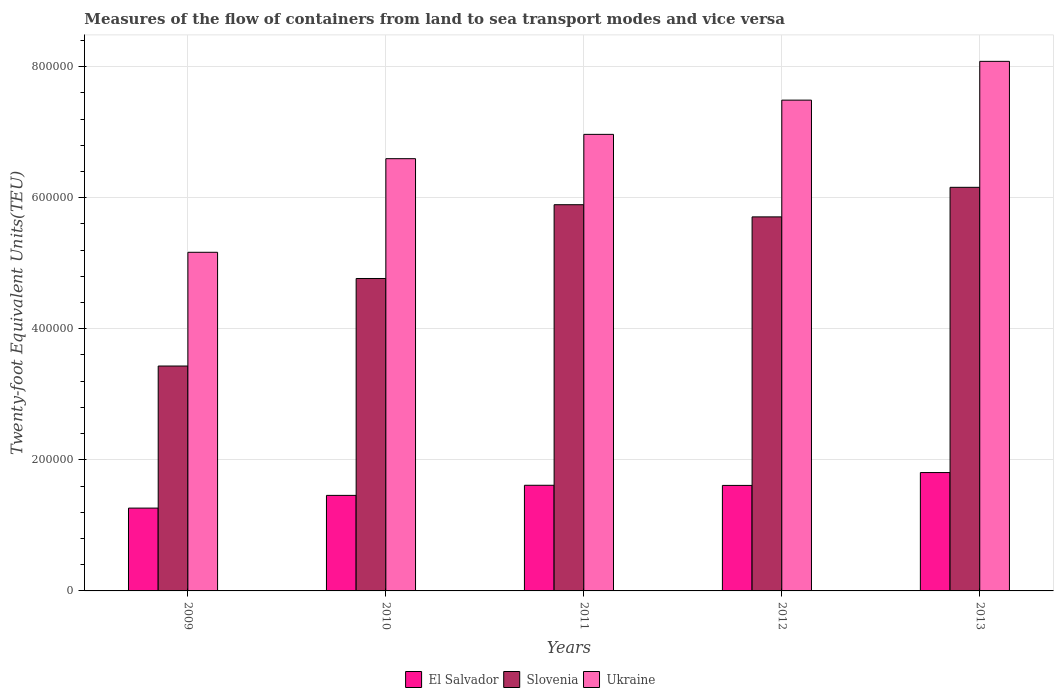How many different coloured bars are there?
Provide a short and direct response. 3. How many groups of bars are there?
Provide a short and direct response. 5. Are the number of bars on each tick of the X-axis equal?
Give a very brief answer. Yes. In how many cases, is the number of bars for a given year not equal to the number of legend labels?
Your response must be concise. 0. What is the container port traffic in Slovenia in 2009?
Keep it short and to the point. 3.43e+05. Across all years, what is the maximum container port traffic in El Salvador?
Your answer should be very brief. 1.81e+05. Across all years, what is the minimum container port traffic in Slovenia?
Your answer should be very brief. 3.43e+05. In which year was the container port traffic in El Salvador minimum?
Your answer should be compact. 2009. What is the total container port traffic in Ukraine in the graph?
Your answer should be very brief. 3.43e+06. What is the difference between the container port traffic in El Salvador in 2010 and that in 2013?
Your answer should be compact. -3.48e+04. What is the difference between the container port traffic in Slovenia in 2011 and the container port traffic in Ukraine in 2010?
Offer a very short reply. -7.02e+04. What is the average container port traffic in El Salvador per year?
Provide a short and direct response. 1.55e+05. In the year 2013, what is the difference between the container port traffic in Ukraine and container port traffic in Slovenia?
Offer a terse response. 1.92e+05. What is the ratio of the container port traffic in El Salvador in 2010 to that in 2013?
Your answer should be compact. 0.81. Is the container port traffic in El Salvador in 2011 less than that in 2012?
Keep it short and to the point. No. Is the difference between the container port traffic in Ukraine in 2011 and 2013 greater than the difference between the container port traffic in Slovenia in 2011 and 2013?
Your answer should be compact. No. What is the difference between the highest and the second highest container port traffic in Ukraine?
Your response must be concise. 5.92e+04. What is the difference between the highest and the lowest container port traffic in Ukraine?
Your answer should be compact. 2.91e+05. In how many years, is the container port traffic in Ukraine greater than the average container port traffic in Ukraine taken over all years?
Provide a succinct answer. 3. What does the 3rd bar from the left in 2010 represents?
Give a very brief answer. Ukraine. What does the 1st bar from the right in 2010 represents?
Provide a short and direct response. Ukraine. How many bars are there?
Make the answer very short. 15. Are all the bars in the graph horizontal?
Your answer should be compact. No. What is the difference between two consecutive major ticks on the Y-axis?
Offer a terse response. 2.00e+05. Does the graph contain grids?
Give a very brief answer. Yes. How are the legend labels stacked?
Make the answer very short. Horizontal. What is the title of the graph?
Make the answer very short. Measures of the flow of containers from land to sea transport modes and vice versa. Does "Grenada" appear as one of the legend labels in the graph?
Give a very brief answer. No. What is the label or title of the Y-axis?
Offer a terse response. Twenty-foot Equivalent Units(TEU). What is the Twenty-foot Equivalent Units(TEU) of El Salvador in 2009?
Keep it short and to the point. 1.26e+05. What is the Twenty-foot Equivalent Units(TEU) in Slovenia in 2009?
Give a very brief answer. 3.43e+05. What is the Twenty-foot Equivalent Units(TEU) in Ukraine in 2009?
Give a very brief answer. 5.17e+05. What is the Twenty-foot Equivalent Units(TEU) of El Salvador in 2010?
Offer a very short reply. 1.46e+05. What is the Twenty-foot Equivalent Units(TEU) in Slovenia in 2010?
Make the answer very short. 4.77e+05. What is the Twenty-foot Equivalent Units(TEU) of Ukraine in 2010?
Make the answer very short. 6.60e+05. What is the Twenty-foot Equivalent Units(TEU) in El Salvador in 2011?
Provide a short and direct response. 1.61e+05. What is the Twenty-foot Equivalent Units(TEU) in Slovenia in 2011?
Your response must be concise. 5.89e+05. What is the Twenty-foot Equivalent Units(TEU) of Ukraine in 2011?
Offer a terse response. 6.97e+05. What is the Twenty-foot Equivalent Units(TEU) in El Salvador in 2012?
Offer a terse response. 1.61e+05. What is the Twenty-foot Equivalent Units(TEU) in Slovenia in 2012?
Offer a terse response. 5.71e+05. What is the Twenty-foot Equivalent Units(TEU) of Ukraine in 2012?
Your answer should be very brief. 7.49e+05. What is the Twenty-foot Equivalent Units(TEU) in El Salvador in 2013?
Your response must be concise. 1.81e+05. What is the Twenty-foot Equivalent Units(TEU) in Slovenia in 2013?
Your response must be concise. 6.16e+05. What is the Twenty-foot Equivalent Units(TEU) of Ukraine in 2013?
Offer a very short reply. 8.08e+05. Across all years, what is the maximum Twenty-foot Equivalent Units(TEU) in El Salvador?
Provide a short and direct response. 1.81e+05. Across all years, what is the maximum Twenty-foot Equivalent Units(TEU) of Slovenia?
Your answer should be very brief. 6.16e+05. Across all years, what is the maximum Twenty-foot Equivalent Units(TEU) of Ukraine?
Your answer should be very brief. 8.08e+05. Across all years, what is the minimum Twenty-foot Equivalent Units(TEU) in El Salvador?
Keep it short and to the point. 1.26e+05. Across all years, what is the minimum Twenty-foot Equivalent Units(TEU) in Slovenia?
Provide a short and direct response. 3.43e+05. Across all years, what is the minimum Twenty-foot Equivalent Units(TEU) in Ukraine?
Provide a short and direct response. 5.17e+05. What is the total Twenty-foot Equivalent Units(TEU) of El Salvador in the graph?
Provide a short and direct response. 7.75e+05. What is the total Twenty-foot Equivalent Units(TEU) in Slovenia in the graph?
Your response must be concise. 2.60e+06. What is the total Twenty-foot Equivalent Units(TEU) of Ukraine in the graph?
Provide a short and direct response. 3.43e+06. What is the difference between the Twenty-foot Equivalent Units(TEU) of El Salvador in 2009 and that in 2010?
Make the answer very short. -1.94e+04. What is the difference between the Twenty-foot Equivalent Units(TEU) of Slovenia in 2009 and that in 2010?
Offer a very short reply. -1.34e+05. What is the difference between the Twenty-foot Equivalent Units(TEU) in Ukraine in 2009 and that in 2010?
Offer a very short reply. -1.43e+05. What is the difference between the Twenty-foot Equivalent Units(TEU) of El Salvador in 2009 and that in 2011?
Provide a short and direct response. -3.48e+04. What is the difference between the Twenty-foot Equivalent Units(TEU) in Slovenia in 2009 and that in 2011?
Ensure brevity in your answer.  -2.46e+05. What is the difference between the Twenty-foot Equivalent Units(TEU) of Ukraine in 2009 and that in 2011?
Your answer should be compact. -1.80e+05. What is the difference between the Twenty-foot Equivalent Units(TEU) in El Salvador in 2009 and that in 2012?
Your response must be concise. -3.46e+04. What is the difference between the Twenty-foot Equivalent Units(TEU) in Slovenia in 2009 and that in 2012?
Provide a succinct answer. -2.28e+05. What is the difference between the Twenty-foot Equivalent Units(TEU) in Ukraine in 2009 and that in 2012?
Make the answer very short. -2.32e+05. What is the difference between the Twenty-foot Equivalent Units(TEU) of El Salvador in 2009 and that in 2013?
Make the answer very short. -5.42e+04. What is the difference between the Twenty-foot Equivalent Units(TEU) of Slovenia in 2009 and that in 2013?
Ensure brevity in your answer.  -2.73e+05. What is the difference between the Twenty-foot Equivalent Units(TEU) in Ukraine in 2009 and that in 2013?
Provide a succinct answer. -2.91e+05. What is the difference between the Twenty-foot Equivalent Units(TEU) of El Salvador in 2010 and that in 2011?
Give a very brief answer. -1.54e+04. What is the difference between the Twenty-foot Equivalent Units(TEU) of Slovenia in 2010 and that in 2011?
Provide a succinct answer. -1.13e+05. What is the difference between the Twenty-foot Equivalent Units(TEU) of Ukraine in 2010 and that in 2011?
Offer a terse response. -3.71e+04. What is the difference between the Twenty-foot Equivalent Units(TEU) of El Salvador in 2010 and that in 2012?
Make the answer very short. -1.52e+04. What is the difference between the Twenty-foot Equivalent Units(TEU) of Slovenia in 2010 and that in 2012?
Offer a very short reply. -9.40e+04. What is the difference between the Twenty-foot Equivalent Units(TEU) of Ukraine in 2010 and that in 2012?
Provide a short and direct response. -8.93e+04. What is the difference between the Twenty-foot Equivalent Units(TEU) of El Salvador in 2010 and that in 2013?
Offer a terse response. -3.48e+04. What is the difference between the Twenty-foot Equivalent Units(TEU) in Slovenia in 2010 and that in 2013?
Keep it short and to the point. -1.39e+05. What is the difference between the Twenty-foot Equivalent Units(TEU) of Ukraine in 2010 and that in 2013?
Your answer should be very brief. -1.49e+05. What is the difference between the Twenty-foot Equivalent Units(TEU) of Slovenia in 2011 and that in 2012?
Offer a very short reply. 1.86e+04. What is the difference between the Twenty-foot Equivalent Units(TEU) in Ukraine in 2011 and that in 2012?
Keep it short and to the point. -5.22e+04. What is the difference between the Twenty-foot Equivalent Units(TEU) of El Salvador in 2011 and that in 2013?
Your answer should be compact. -1.94e+04. What is the difference between the Twenty-foot Equivalent Units(TEU) of Slovenia in 2011 and that in 2013?
Your response must be concise. -2.65e+04. What is the difference between the Twenty-foot Equivalent Units(TEU) in Ukraine in 2011 and that in 2013?
Offer a terse response. -1.11e+05. What is the difference between the Twenty-foot Equivalent Units(TEU) in El Salvador in 2012 and that in 2013?
Make the answer very short. -1.96e+04. What is the difference between the Twenty-foot Equivalent Units(TEU) of Slovenia in 2012 and that in 2013?
Your answer should be compact. -4.51e+04. What is the difference between the Twenty-foot Equivalent Units(TEU) of Ukraine in 2012 and that in 2013?
Give a very brief answer. -5.92e+04. What is the difference between the Twenty-foot Equivalent Units(TEU) in El Salvador in 2009 and the Twenty-foot Equivalent Units(TEU) in Slovenia in 2010?
Ensure brevity in your answer.  -3.50e+05. What is the difference between the Twenty-foot Equivalent Units(TEU) of El Salvador in 2009 and the Twenty-foot Equivalent Units(TEU) of Ukraine in 2010?
Keep it short and to the point. -5.33e+05. What is the difference between the Twenty-foot Equivalent Units(TEU) of Slovenia in 2009 and the Twenty-foot Equivalent Units(TEU) of Ukraine in 2010?
Your answer should be compact. -3.16e+05. What is the difference between the Twenty-foot Equivalent Units(TEU) of El Salvador in 2009 and the Twenty-foot Equivalent Units(TEU) of Slovenia in 2011?
Make the answer very short. -4.63e+05. What is the difference between the Twenty-foot Equivalent Units(TEU) in El Salvador in 2009 and the Twenty-foot Equivalent Units(TEU) in Ukraine in 2011?
Your response must be concise. -5.70e+05. What is the difference between the Twenty-foot Equivalent Units(TEU) of Slovenia in 2009 and the Twenty-foot Equivalent Units(TEU) of Ukraine in 2011?
Your response must be concise. -3.53e+05. What is the difference between the Twenty-foot Equivalent Units(TEU) of El Salvador in 2009 and the Twenty-foot Equivalent Units(TEU) of Slovenia in 2012?
Provide a short and direct response. -4.44e+05. What is the difference between the Twenty-foot Equivalent Units(TEU) of El Salvador in 2009 and the Twenty-foot Equivalent Units(TEU) of Ukraine in 2012?
Your answer should be very brief. -6.23e+05. What is the difference between the Twenty-foot Equivalent Units(TEU) in Slovenia in 2009 and the Twenty-foot Equivalent Units(TEU) in Ukraine in 2012?
Your answer should be very brief. -4.06e+05. What is the difference between the Twenty-foot Equivalent Units(TEU) of El Salvador in 2009 and the Twenty-foot Equivalent Units(TEU) of Slovenia in 2013?
Give a very brief answer. -4.89e+05. What is the difference between the Twenty-foot Equivalent Units(TEU) of El Salvador in 2009 and the Twenty-foot Equivalent Units(TEU) of Ukraine in 2013?
Keep it short and to the point. -6.82e+05. What is the difference between the Twenty-foot Equivalent Units(TEU) in Slovenia in 2009 and the Twenty-foot Equivalent Units(TEU) in Ukraine in 2013?
Provide a succinct answer. -4.65e+05. What is the difference between the Twenty-foot Equivalent Units(TEU) of El Salvador in 2010 and the Twenty-foot Equivalent Units(TEU) of Slovenia in 2011?
Offer a very short reply. -4.44e+05. What is the difference between the Twenty-foot Equivalent Units(TEU) of El Salvador in 2010 and the Twenty-foot Equivalent Units(TEU) of Ukraine in 2011?
Keep it short and to the point. -5.51e+05. What is the difference between the Twenty-foot Equivalent Units(TEU) in Slovenia in 2010 and the Twenty-foot Equivalent Units(TEU) in Ukraine in 2011?
Offer a terse response. -2.20e+05. What is the difference between the Twenty-foot Equivalent Units(TEU) in El Salvador in 2010 and the Twenty-foot Equivalent Units(TEU) in Slovenia in 2012?
Give a very brief answer. -4.25e+05. What is the difference between the Twenty-foot Equivalent Units(TEU) of El Salvador in 2010 and the Twenty-foot Equivalent Units(TEU) of Ukraine in 2012?
Give a very brief answer. -6.03e+05. What is the difference between the Twenty-foot Equivalent Units(TEU) in Slovenia in 2010 and the Twenty-foot Equivalent Units(TEU) in Ukraine in 2012?
Your answer should be compact. -2.72e+05. What is the difference between the Twenty-foot Equivalent Units(TEU) in El Salvador in 2010 and the Twenty-foot Equivalent Units(TEU) in Slovenia in 2013?
Ensure brevity in your answer.  -4.70e+05. What is the difference between the Twenty-foot Equivalent Units(TEU) of El Salvador in 2010 and the Twenty-foot Equivalent Units(TEU) of Ukraine in 2013?
Your answer should be compact. -6.62e+05. What is the difference between the Twenty-foot Equivalent Units(TEU) of Slovenia in 2010 and the Twenty-foot Equivalent Units(TEU) of Ukraine in 2013?
Your answer should be very brief. -3.31e+05. What is the difference between the Twenty-foot Equivalent Units(TEU) in El Salvador in 2011 and the Twenty-foot Equivalent Units(TEU) in Slovenia in 2012?
Ensure brevity in your answer.  -4.10e+05. What is the difference between the Twenty-foot Equivalent Units(TEU) in El Salvador in 2011 and the Twenty-foot Equivalent Units(TEU) in Ukraine in 2012?
Give a very brief answer. -5.88e+05. What is the difference between the Twenty-foot Equivalent Units(TEU) of Slovenia in 2011 and the Twenty-foot Equivalent Units(TEU) of Ukraine in 2012?
Provide a succinct answer. -1.60e+05. What is the difference between the Twenty-foot Equivalent Units(TEU) of El Salvador in 2011 and the Twenty-foot Equivalent Units(TEU) of Slovenia in 2013?
Your answer should be very brief. -4.55e+05. What is the difference between the Twenty-foot Equivalent Units(TEU) in El Salvador in 2011 and the Twenty-foot Equivalent Units(TEU) in Ukraine in 2013?
Provide a succinct answer. -6.47e+05. What is the difference between the Twenty-foot Equivalent Units(TEU) of Slovenia in 2011 and the Twenty-foot Equivalent Units(TEU) of Ukraine in 2013?
Provide a succinct answer. -2.19e+05. What is the difference between the Twenty-foot Equivalent Units(TEU) in El Salvador in 2012 and the Twenty-foot Equivalent Units(TEU) in Slovenia in 2013?
Your response must be concise. -4.55e+05. What is the difference between the Twenty-foot Equivalent Units(TEU) in El Salvador in 2012 and the Twenty-foot Equivalent Units(TEU) in Ukraine in 2013?
Your response must be concise. -6.47e+05. What is the difference between the Twenty-foot Equivalent Units(TEU) of Slovenia in 2012 and the Twenty-foot Equivalent Units(TEU) of Ukraine in 2013?
Provide a succinct answer. -2.37e+05. What is the average Twenty-foot Equivalent Units(TEU) of El Salvador per year?
Make the answer very short. 1.55e+05. What is the average Twenty-foot Equivalent Units(TEU) in Slovenia per year?
Offer a very short reply. 5.19e+05. What is the average Twenty-foot Equivalent Units(TEU) of Ukraine per year?
Your answer should be very brief. 6.86e+05. In the year 2009, what is the difference between the Twenty-foot Equivalent Units(TEU) in El Salvador and Twenty-foot Equivalent Units(TEU) in Slovenia?
Provide a short and direct response. -2.17e+05. In the year 2009, what is the difference between the Twenty-foot Equivalent Units(TEU) of El Salvador and Twenty-foot Equivalent Units(TEU) of Ukraine?
Your answer should be compact. -3.90e+05. In the year 2009, what is the difference between the Twenty-foot Equivalent Units(TEU) in Slovenia and Twenty-foot Equivalent Units(TEU) in Ukraine?
Ensure brevity in your answer.  -1.74e+05. In the year 2010, what is the difference between the Twenty-foot Equivalent Units(TEU) in El Salvador and Twenty-foot Equivalent Units(TEU) in Slovenia?
Keep it short and to the point. -3.31e+05. In the year 2010, what is the difference between the Twenty-foot Equivalent Units(TEU) of El Salvador and Twenty-foot Equivalent Units(TEU) of Ukraine?
Make the answer very short. -5.14e+05. In the year 2010, what is the difference between the Twenty-foot Equivalent Units(TEU) in Slovenia and Twenty-foot Equivalent Units(TEU) in Ukraine?
Your response must be concise. -1.83e+05. In the year 2011, what is the difference between the Twenty-foot Equivalent Units(TEU) of El Salvador and Twenty-foot Equivalent Units(TEU) of Slovenia?
Provide a succinct answer. -4.28e+05. In the year 2011, what is the difference between the Twenty-foot Equivalent Units(TEU) of El Salvador and Twenty-foot Equivalent Units(TEU) of Ukraine?
Your answer should be very brief. -5.35e+05. In the year 2011, what is the difference between the Twenty-foot Equivalent Units(TEU) in Slovenia and Twenty-foot Equivalent Units(TEU) in Ukraine?
Provide a short and direct response. -1.07e+05. In the year 2012, what is the difference between the Twenty-foot Equivalent Units(TEU) of El Salvador and Twenty-foot Equivalent Units(TEU) of Slovenia?
Your response must be concise. -4.10e+05. In the year 2012, what is the difference between the Twenty-foot Equivalent Units(TEU) of El Salvador and Twenty-foot Equivalent Units(TEU) of Ukraine?
Offer a very short reply. -5.88e+05. In the year 2012, what is the difference between the Twenty-foot Equivalent Units(TEU) of Slovenia and Twenty-foot Equivalent Units(TEU) of Ukraine?
Offer a very short reply. -1.78e+05. In the year 2013, what is the difference between the Twenty-foot Equivalent Units(TEU) in El Salvador and Twenty-foot Equivalent Units(TEU) in Slovenia?
Offer a terse response. -4.35e+05. In the year 2013, what is the difference between the Twenty-foot Equivalent Units(TEU) in El Salvador and Twenty-foot Equivalent Units(TEU) in Ukraine?
Offer a terse response. -6.27e+05. In the year 2013, what is the difference between the Twenty-foot Equivalent Units(TEU) of Slovenia and Twenty-foot Equivalent Units(TEU) of Ukraine?
Ensure brevity in your answer.  -1.92e+05. What is the ratio of the Twenty-foot Equivalent Units(TEU) in El Salvador in 2009 to that in 2010?
Offer a terse response. 0.87. What is the ratio of the Twenty-foot Equivalent Units(TEU) in Slovenia in 2009 to that in 2010?
Ensure brevity in your answer.  0.72. What is the ratio of the Twenty-foot Equivalent Units(TEU) in Ukraine in 2009 to that in 2010?
Keep it short and to the point. 0.78. What is the ratio of the Twenty-foot Equivalent Units(TEU) of El Salvador in 2009 to that in 2011?
Offer a terse response. 0.78. What is the ratio of the Twenty-foot Equivalent Units(TEU) of Slovenia in 2009 to that in 2011?
Make the answer very short. 0.58. What is the ratio of the Twenty-foot Equivalent Units(TEU) of Ukraine in 2009 to that in 2011?
Make the answer very short. 0.74. What is the ratio of the Twenty-foot Equivalent Units(TEU) in El Salvador in 2009 to that in 2012?
Ensure brevity in your answer.  0.78. What is the ratio of the Twenty-foot Equivalent Units(TEU) in Slovenia in 2009 to that in 2012?
Make the answer very short. 0.6. What is the ratio of the Twenty-foot Equivalent Units(TEU) in Ukraine in 2009 to that in 2012?
Make the answer very short. 0.69. What is the ratio of the Twenty-foot Equivalent Units(TEU) in El Salvador in 2009 to that in 2013?
Make the answer very short. 0.7. What is the ratio of the Twenty-foot Equivalent Units(TEU) in Slovenia in 2009 to that in 2013?
Your answer should be very brief. 0.56. What is the ratio of the Twenty-foot Equivalent Units(TEU) of Ukraine in 2009 to that in 2013?
Provide a short and direct response. 0.64. What is the ratio of the Twenty-foot Equivalent Units(TEU) of El Salvador in 2010 to that in 2011?
Make the answer very short. 0.9. What is the ratio of the Twenty-foot Equivalent Units(TEU) of Slovenia in 2010 to that in 2011?
Your response must be concise. 0.81. What is the ratio of the Twenty-foot Equivalent Units(TEU) in Ukraine in 2010 to that in 2011?
Offer a very short reply. 0.95. What is the ratio of the Twenty-foot Equivalent Units(TEU) of El Salvador in 2010 to that in 2012?
Your answer should be very brief. 0.91. What is the ratio of the Twenty-foot Equivalent Units(TEU) of Slovenia in 2010 to that in 2012?
Ensure brevity in your answer.  0.84. What is the ratio of the Twenty-foot Equivalent Units(TEU) in Ukraine in 2010 to that in 2012?
Keep it short and to the point. 0.88. What is the ratio of the Twenty-foot Equivalent Units(TEU) of El Salvador in 2010 to that in 2013?
Provide a succinct answer. 0.81. What is the ratio of the Twenty-foot Equivalent Units(TEU) in Slovenia in 2010 to that in 2013?
Provide a short and direct response. 0.77. What is the ratio of the Twenty-foot Equivalent Units(TEU) of Ukraine in 2010 to that in 2013?
Keep it short and to the point. 0.82. What is the ratio of the Twenty-foot Equivalent Units(TEU) in El Salvador in 2011 to that in 2012?
Keep it short and to the point. 1. What is the ratio of the Twenty-foot Equivalent Units(TEU) of Slovenia in 2011 to that in 2012?
Offer a very short reply. 1.03. What is the ratio of the Twenty-foot Equivalent Units(TEU) in Ukraine in 2011 to that in 2012?
Your answer should be very brief. 0.93. What is the ratio of the Twenty-foot Equivalent Units(TEU) in El Salvador in 2011 to that in 2013?
Your answer should be compact. 0.89. What is the ratio of the Twenty-foot Equivalent Units(TEU) of Slovenia in 2011 to that in 2013?
Provide a short and direct response. 0.96. What is the ratio of the Twenty-foot Equivalent Units(TEU) in Ukraine in 2011 to that in 2013?
Keep it short and to the point. 0.86. What is the ratio of the Twenty-foot Equivalent Units(TEU) of El Salvador in 2012 to that in 2013?
Ensure brevity in your answer.  0.89. What is the ratio of the Twenty-foot Equivalent Units(TEU) in Slovenia in 2012 to that in 2013?
Provide a succinct answer. 0.93. What is the ratio of the Twenty-foot Equivalent Units(TEU) of Ukraine in 2012 to that in 2013?
Give a very brief answer. 0.93. What is the difference between the highest and the second highest Twenty-foot Equivalent Units(TEU) in El Salvador?
Your response must be concise. 1.94e+04. What is the difference between the highest and the second highest Twenty-foot Equivalent Units(TEU) in Slovenia?
Offer a terse response. 2.65e+04. What is the difference between the highest and the second highest Twenty-foot Equivalent Units(TEU) of Ukraine?
Provide a succinct answer. 5.92e+04. What is the difference between the highest and the lowest Twenty-foot Equivalent Units(TEU) in El Salvador?
Provide a short and direct response. 5.42e+04. What is the difference between the highest and the lowest Twenty-foot Equivalent Units(TEU) in Slovenia?
Offer a very short reply. 2.73e+05. What is the difference between the highest and the lowest Twenty-foot Equivalent Units(TEU) in Ukraine?
Ensure brevity in your answer.  2.91e+05. 